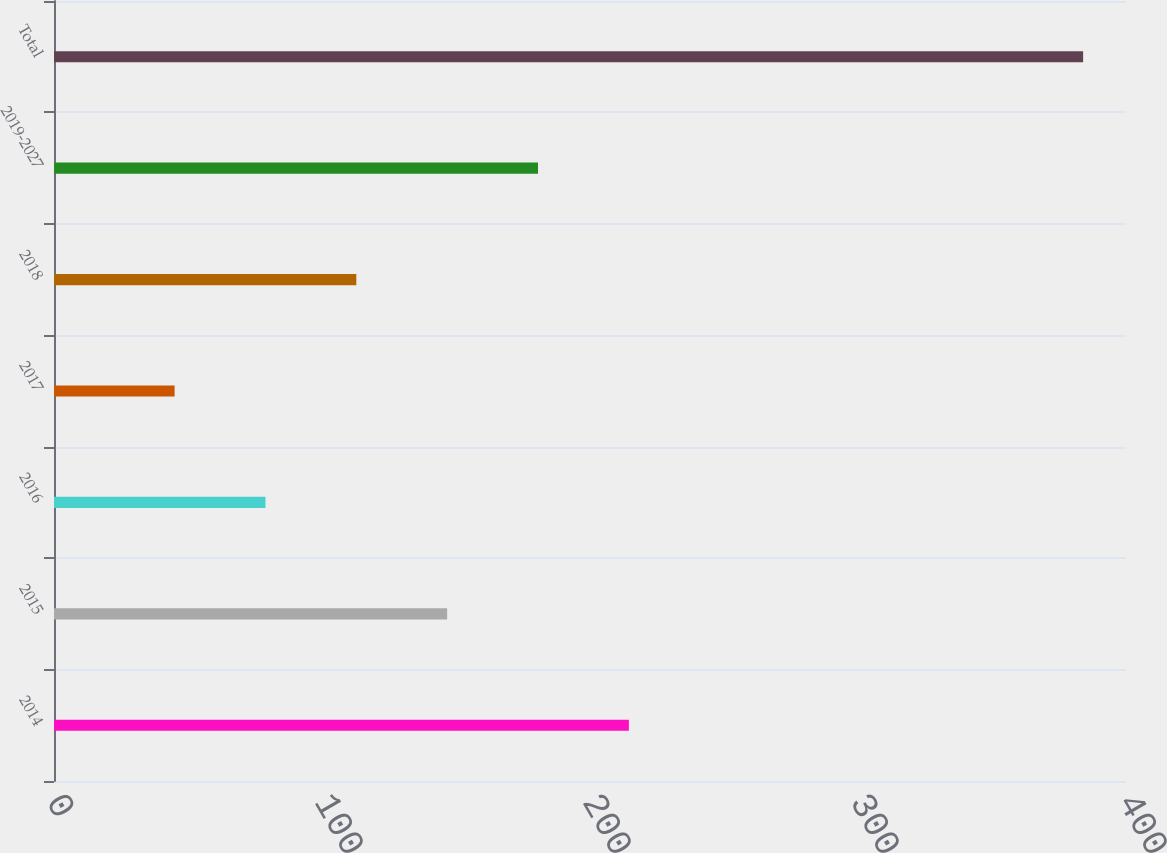Convert chart to OTSL. <chart><loc_0><loc_0><loc_500><loc_500><bar_chart><fcel>2014<fcel>2015<fcel>2016<fcel>2017<fcel>2018<fcel>2019-2027<fcel>Total<nl><fcel>214.5<fcel>146.7<fcel>78.9<fcel>45<fcel>112.8<fcel>180.6<fcel>384<nl></chart> 